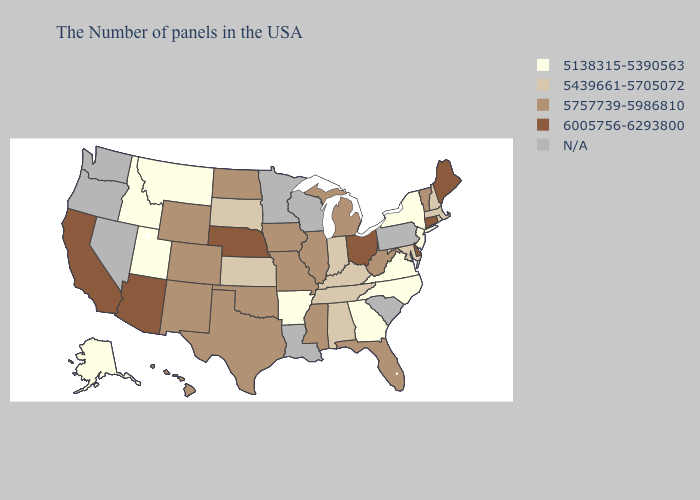Does Delaware have the highest value in the USA?
Write a very short answer. Yes. What is the highest value in the USA?
Short answer required. 6005756-6293800. Which states hav the highest value in the South?
Write a very short answer. Delaware. Among the states that border New York , which have the lowest value?
Keep it brief. New Jersey. What is the value of Maryland?
Concise answer only. 5439661-5705072. Among the states that border Connecticut , does New York have the lowest value?
Concise answer only. Yes. Among the states that border New Mexico , does Colorado have the lowest value?
Give a very brief answer. No. What is the value of Minnesota?
Concise answer only. N/A. What is the highest value in the USA?
Answer briefly. 6005756-6293800. Does the map have missing data?
Quick response, please. Yes. Name the states that have a value in the range 5757739-5986810?
Give a very brief answer. Vermont, West Virginia, Florida, Michigan, Illinois, Mississippi, Missouri, Iowa, Oklahoma, Texas, North Dakota, Wyoming, Colorado, New Mexico, Hawaii. What is the value of Alaska?
Keep it brief. 5138315-5390563. Name the states that have a value in the range 5757739-5986810?
Write a very short answer. Vermont, West Virginia, Florida, Michigan, Illinois, Mississippi, Missouri, Iowa, Oklahoma, Texas, North Dakota, Wyoming, Colorado, New Mexico, Hawaii. What is the lowest value in the USA?
Answer briefly. 5138315-5390563. 